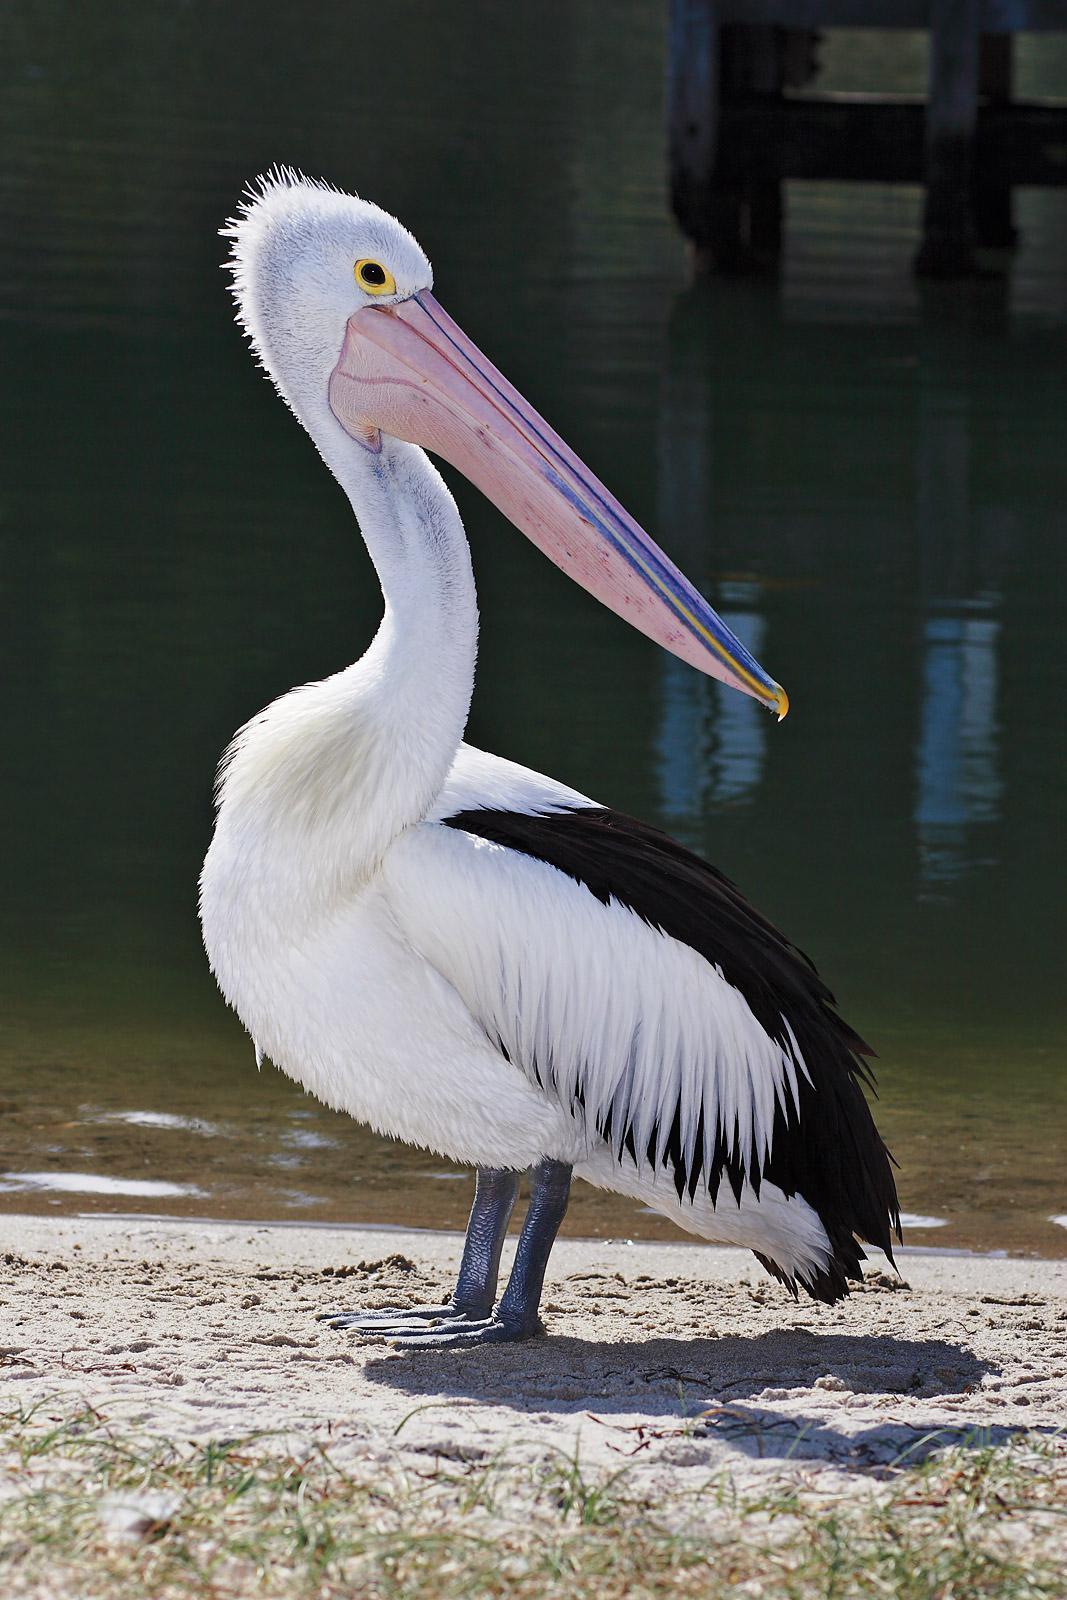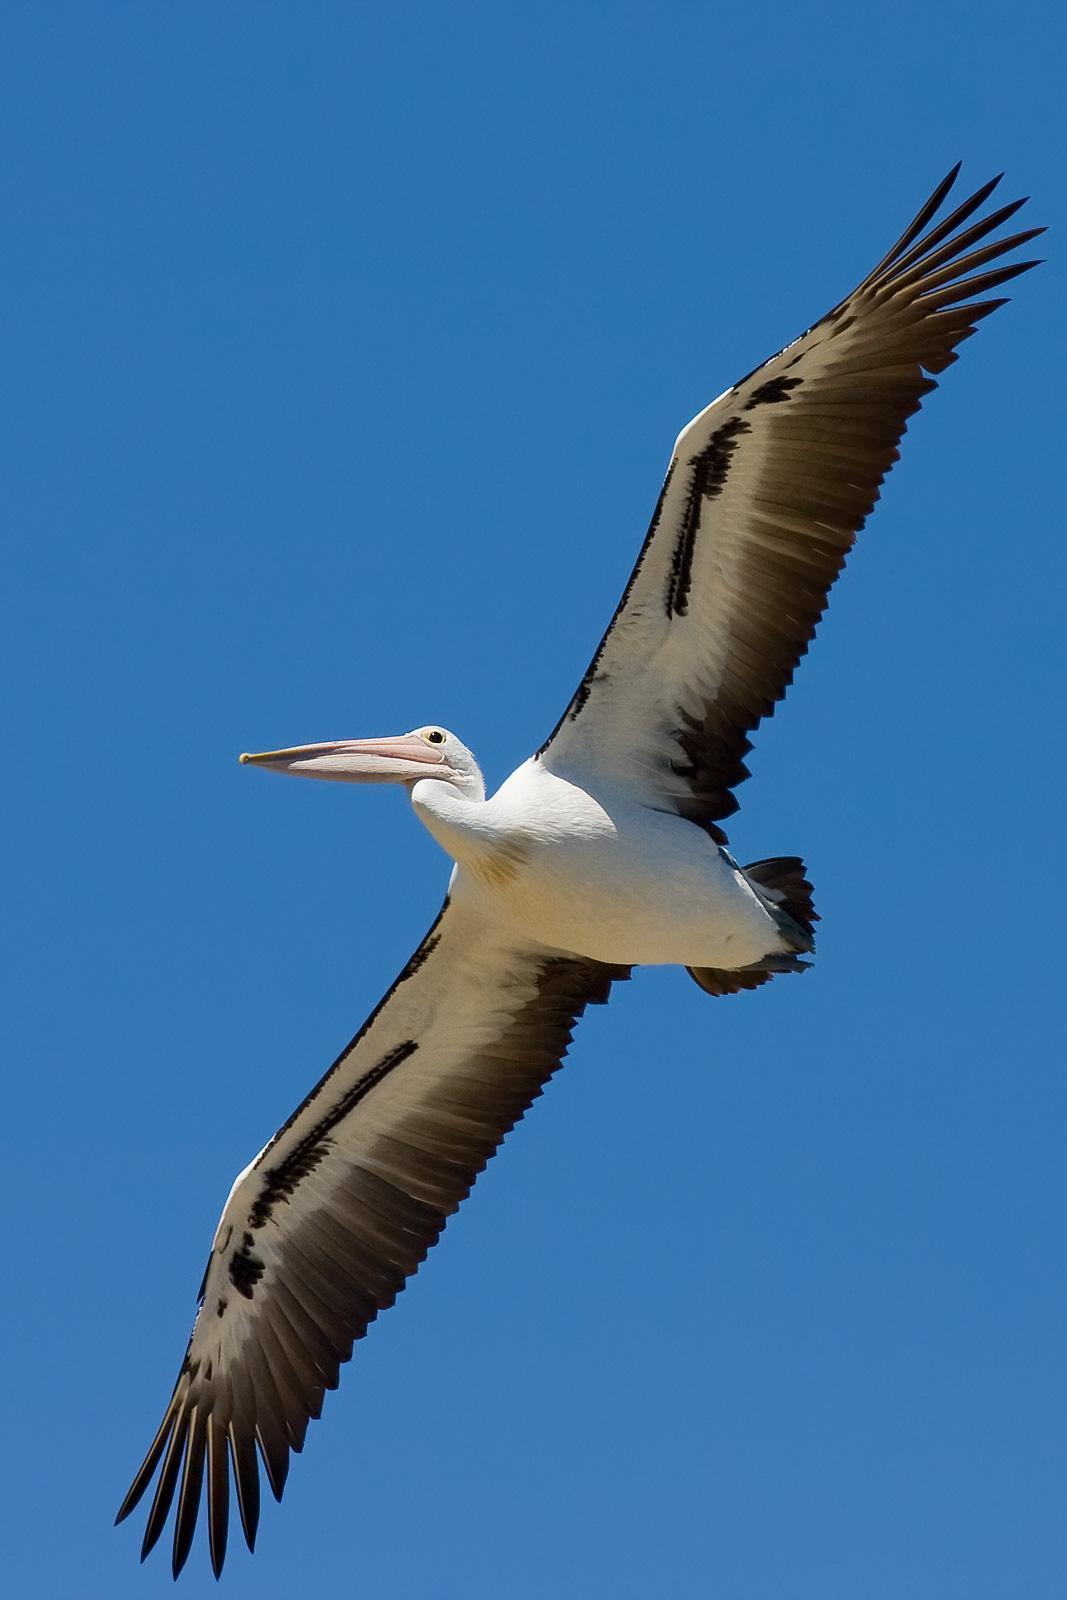The first image is the image on the left, the second image is the image on the right. Assess this claim about the two images: "One image includes a pelican with it's beak open wide.". Correct or not? Answer yes or no. No. The first image is the image on the left, the second image is the image on the right. For the images displayed, is the sentence "One of the pelicans is flying." factually correct? Answer yes or no. Yes. 